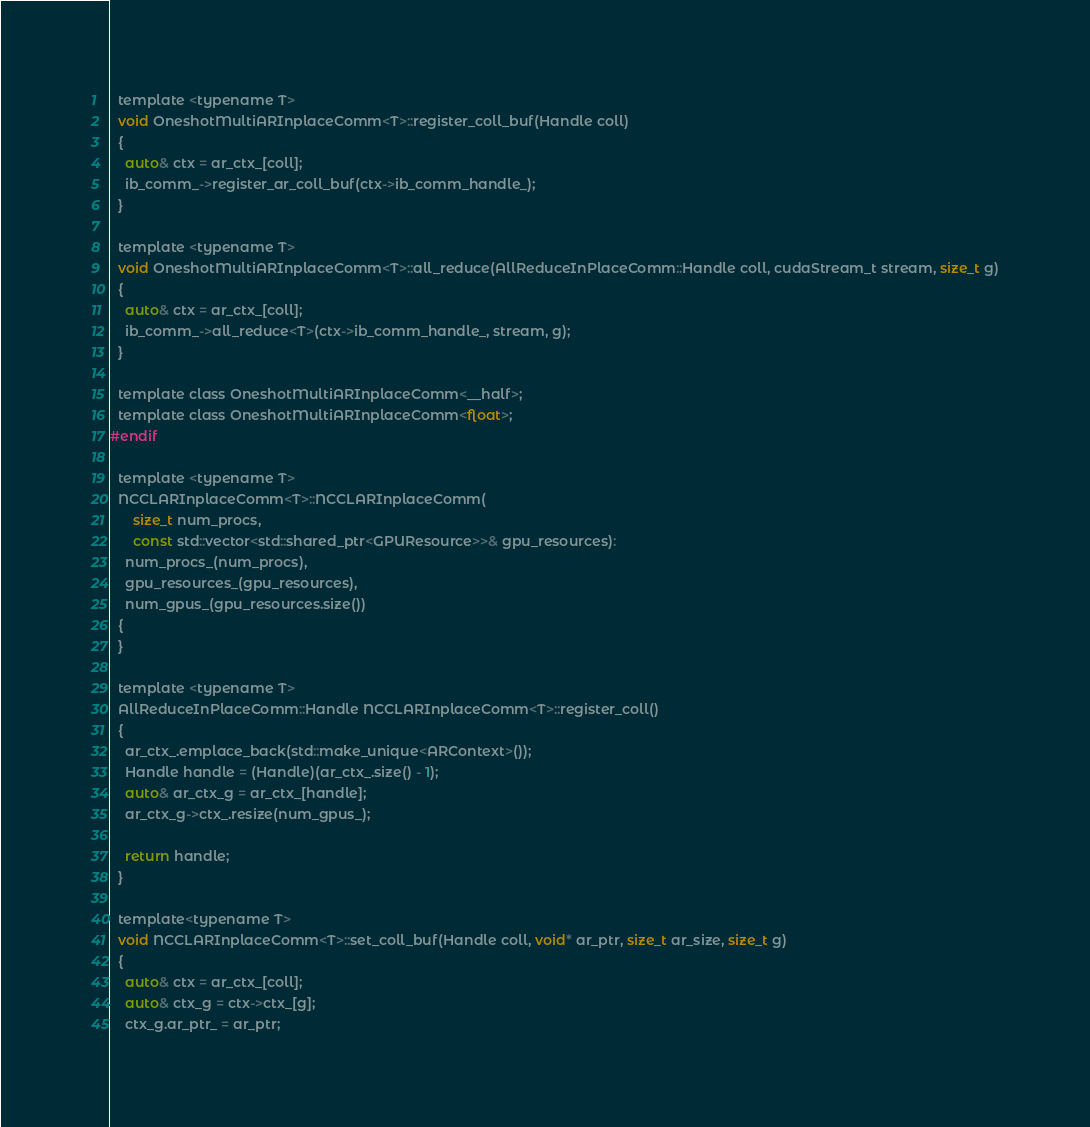<code> <loc_0><loc_0><loc_500><loc_500><_Cuda_>
  template <typename T>
  void OneshotMultiARInplaceComm<T>::register_coll_buf(Handle coll)
  {
    auto& ctx = ar_ctx_[coll];
    ib_comm_->register_ar_coll_buf(ctx->ib_comm_handle_);
  }

  template <typename T>
  void OneshotMultiARInplaceComm<T>::all_reduce(AllReduceInPlaceComm::Handle coll, cudaStream_t stream, size_t g)
  {
    auto& ctx = ar_ctx_[coll];
    ib_comm_->all_reduce<T>(ctx->ib_comm_handle_, stream, g);
  }
  
  template class OneshotMultiARInplaceComm<__half>;
  template class OneshotMultiARInplaceComm<float>;
#endif

  template <typename T>
  NCCLARInplaceComm<T>::NCCLARInplaceComm(
      size_t num_procs,
      const std::vector<std::shared_ptr<GPUResource>>& gpu_resources):
    num_procs_(num_procs),
    gpu_resources_(gpu_resources),
    num_gpus_(gpu_resources.size())
  {
  }

  template <typename T>
  AllReduceInPlaceComm::Handle NCCLARInplaceComm<T>::register_coll()
  {
    ar_ctx_.emplace_back(std::make_unique<ARContext>());
    Handle handle = (Handle)(ar_ctx_.size() - 1);
    auto& ar_ctx_g = ar_ctx_[handle];
    ar_ctx_g->ctx_.resize(num_gpus_);
    
    return handle;
  }

  template<typename T>
  void NCCLARInplaceComm<T>::set_coll_buf(Handle coll, void* ar_ptr, size_t ar_size, size_t g)
  {
    auto& ctx = ar_ctx_[coll];
    auto& ctx_g = ctx->ctx_[g];
    ctx_g.ar_ptr_ = ar_ptr;</code> 